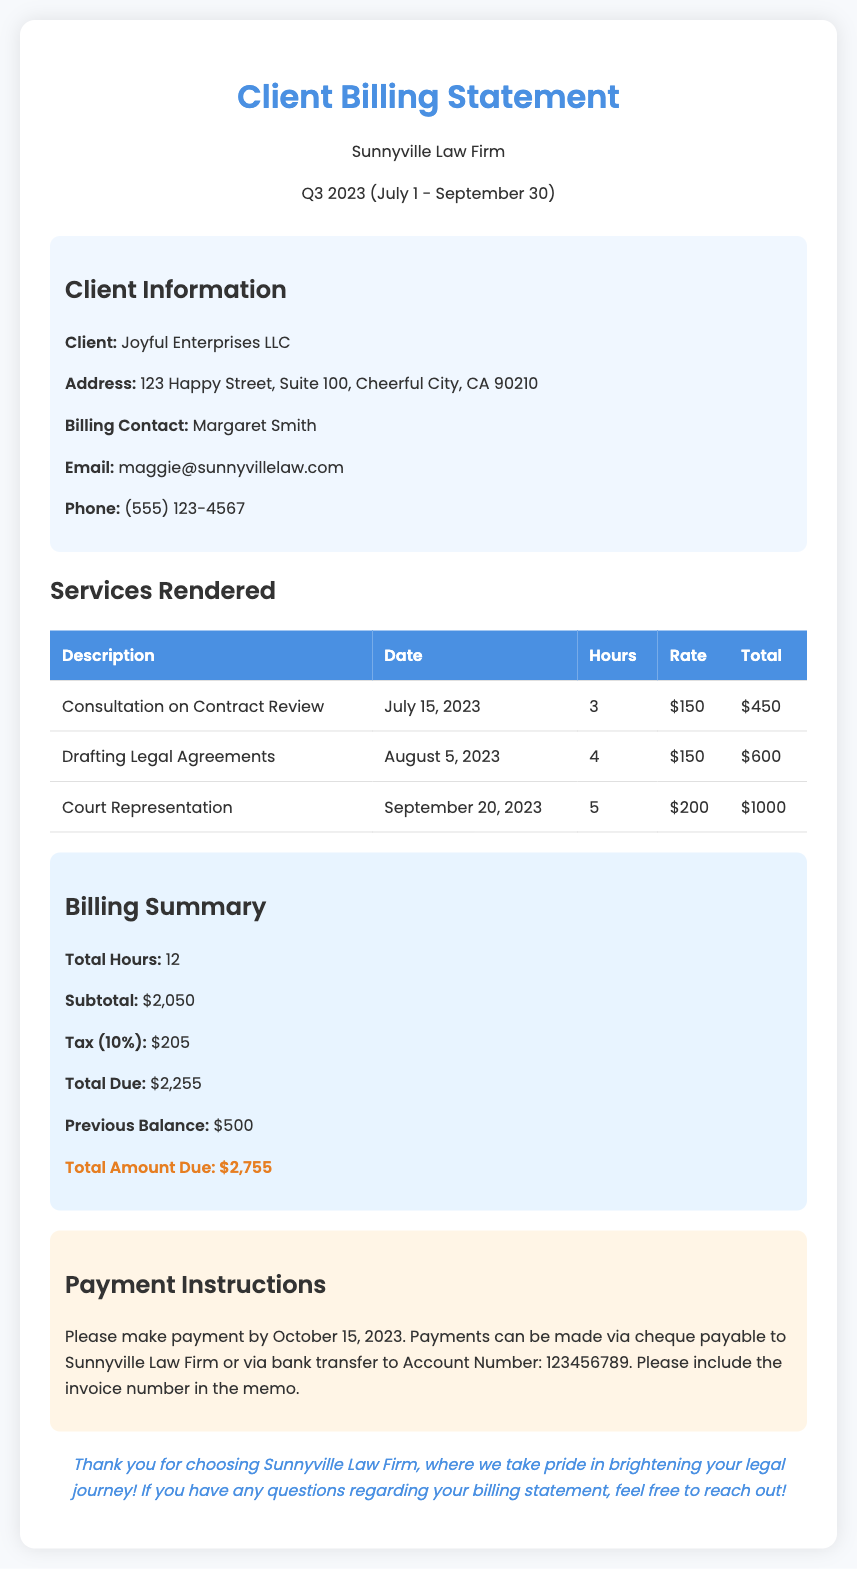What is the total hours worked? The total hours worked are detailed in the billing summary section, indicating a combined total from the services rendered.
Answer: 12 What was the date of the court representation? The document specifies the date of court representation within the services rendered section.
Answer: September 20, 2023 What is the subtotal before tax? The subtotal before tax is clearly stated in the billing summary section of the document.
Answer: $2,050 Who is the billing contact? The billing contact information is listed in the client information section.
Answer: Margaret Smith What is the mailing deadline for payment? The payment instructions highlight a specific date by which payment should be made.
Answer: October 15, 2023 What is the total amount due including the previous balance? The total amount due is calculated based on the billing summary and includes the previous balance.
Answer: $2,755 How much was charged for the drafting of legal agreements? The total for the drafting service is included in the services rendered table, specifying the charge.
Answer: $600 What was the tax rate applied? The tax rate applied is noted in the billing summary section of the document.
Answer: 10% What is the address of the client? The address of the client is listed under the client information section.
Answer: 123 Happy Street, Suite 100, Cheerful City, CA 90210 